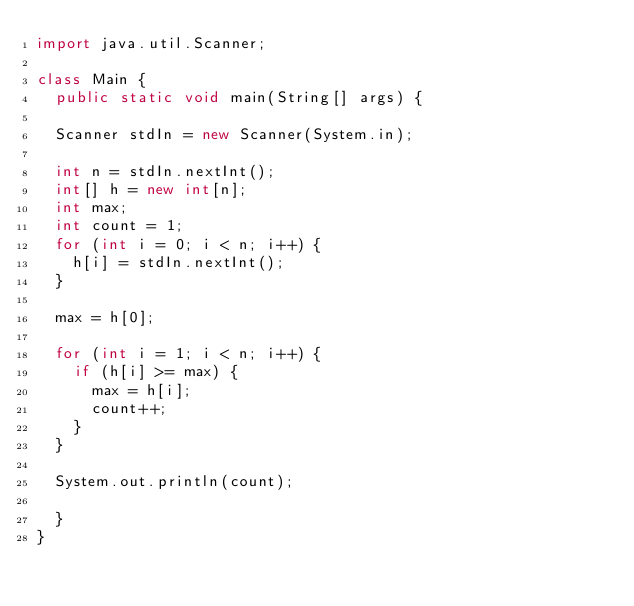<code> <loc_0><loc_0><loc_500><loc_500><_Java_>import java.util.Scanner;

class Main {
	public static void main(String[] args) {
	
	Scanner stdIn = new Scanner(System.in);
	
	int n = stdIn.nextInt();
	int[] h = new int[n];
	int max;
	int count = 1;
	for (int i = 0; i < n; i++) {
		h[i] = stdIn.nextInt();
	}
	
	max = h[0];
	
	for (int i = 1; i < n; i++) {
		if (h[i] >= max) {
			max = h[i];
			count++;
		}
	}
	
	System.out.println(count);
	
	}
}</code> 